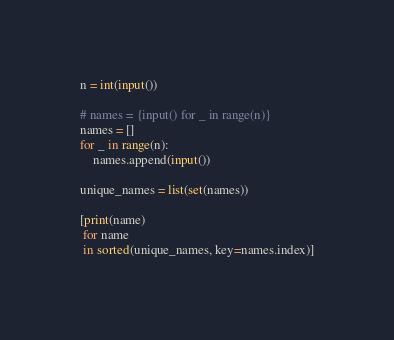Convert code to text. <code><loc_0><loc_0><loc_500><loc_500><_Python_>n = int(input())

# names = {input() for _ in range(n)}
names = []
for _ in range(n):
    names.append(input())

unique_names = list(set(names))

[print(name)
 for name
 in sorted(unique_names, key=names.index)]

</code> 